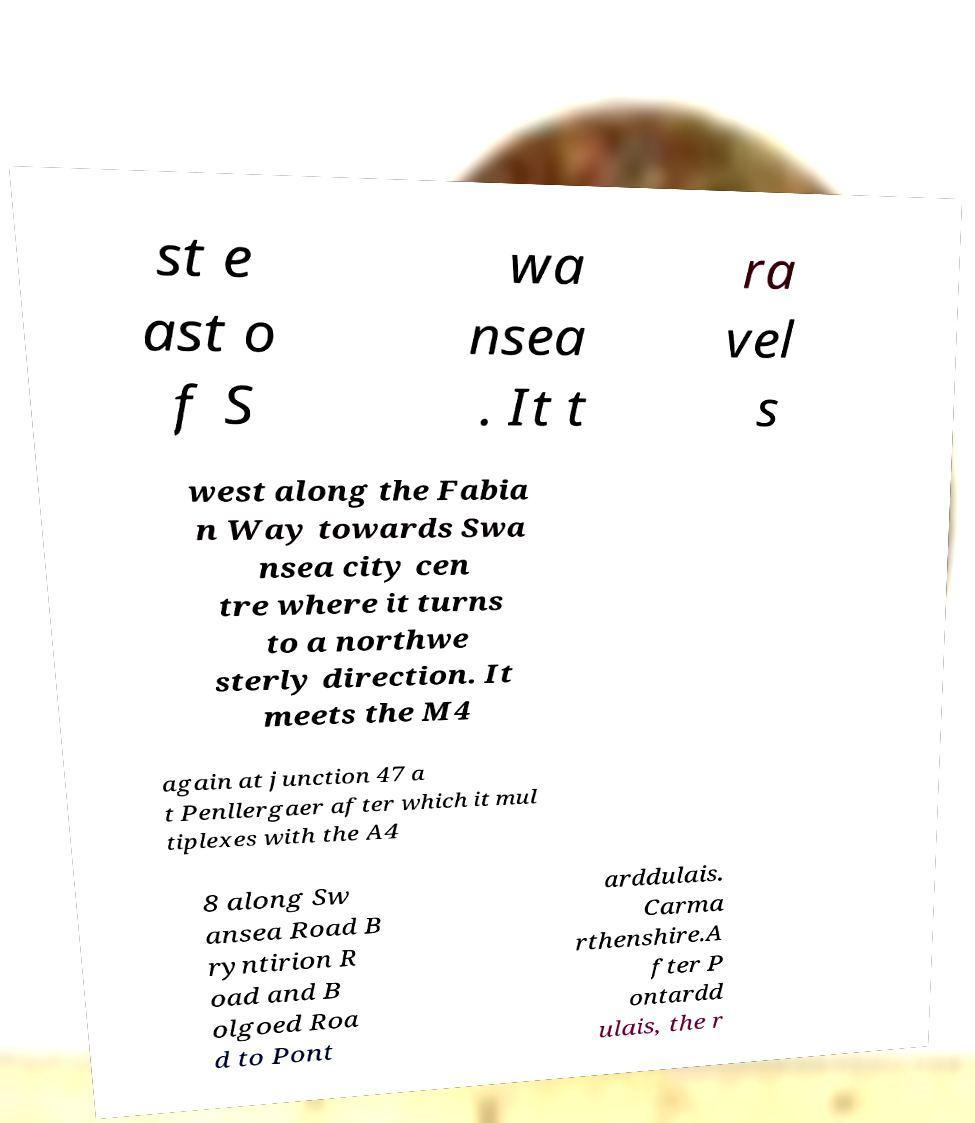Can you read and provide the text displayed in the image?This photo seems to have some interesting text. Can you extract and type it out for me? st e ast o f S wa nsea . It t ra vel s west along the Fabia n Way towards Swa nsea city cen tre where it turns to a northwe sterly direction. It meets the M4 again at junction 47 a t Penllergaer after which it mul tiplexes with the A4 8 along Sw ansea Road B ryntirion R oad and B olgoed Roa d to Pont arddulais. Carma rthenshire.A fter P ontardd ulais, the r 